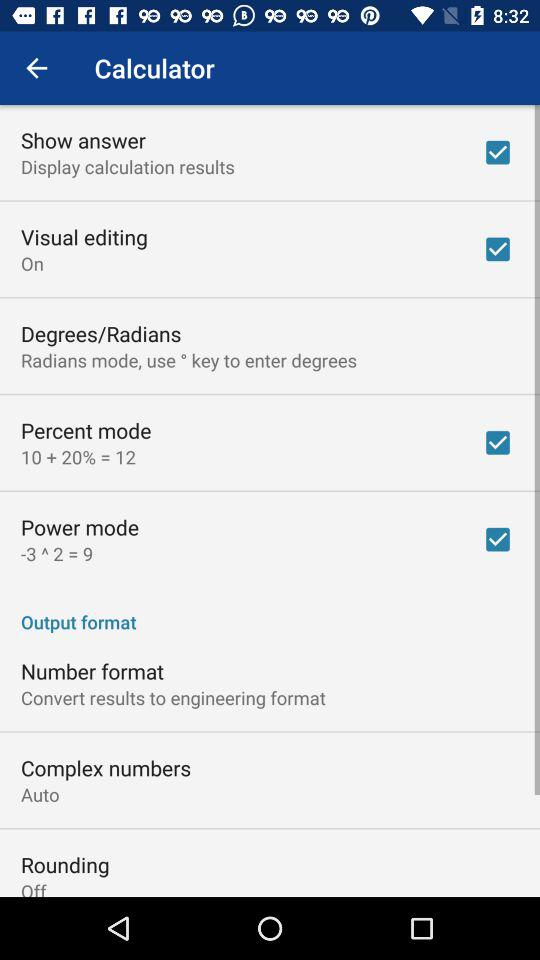What are the checked options? The checked options are "Show answer", "Visual editing", "Percent mode" and "Power mode". 